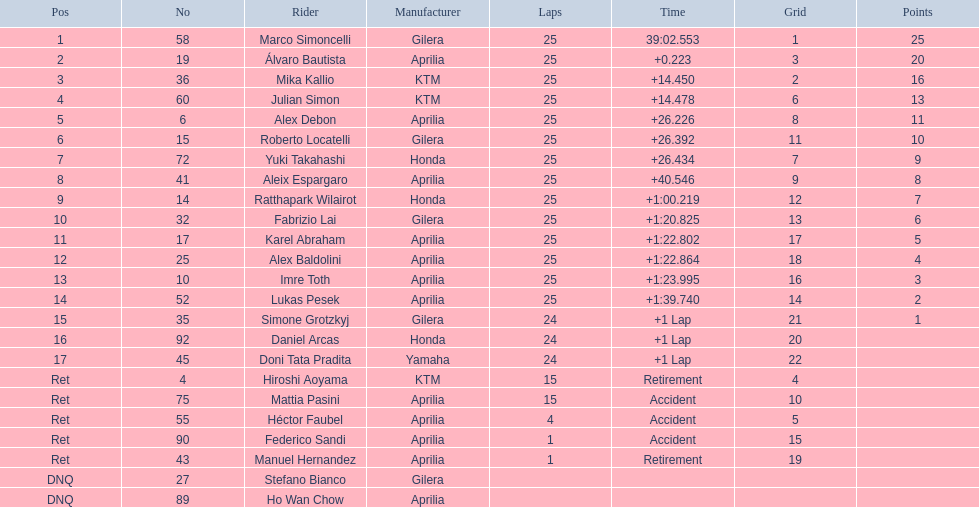How many loops did marco achieve? 25. How many loops did hiroshi achieve? 15. Which of these amounts is more? 25. Who managed this amount of loops? Marco Simoncelli. 